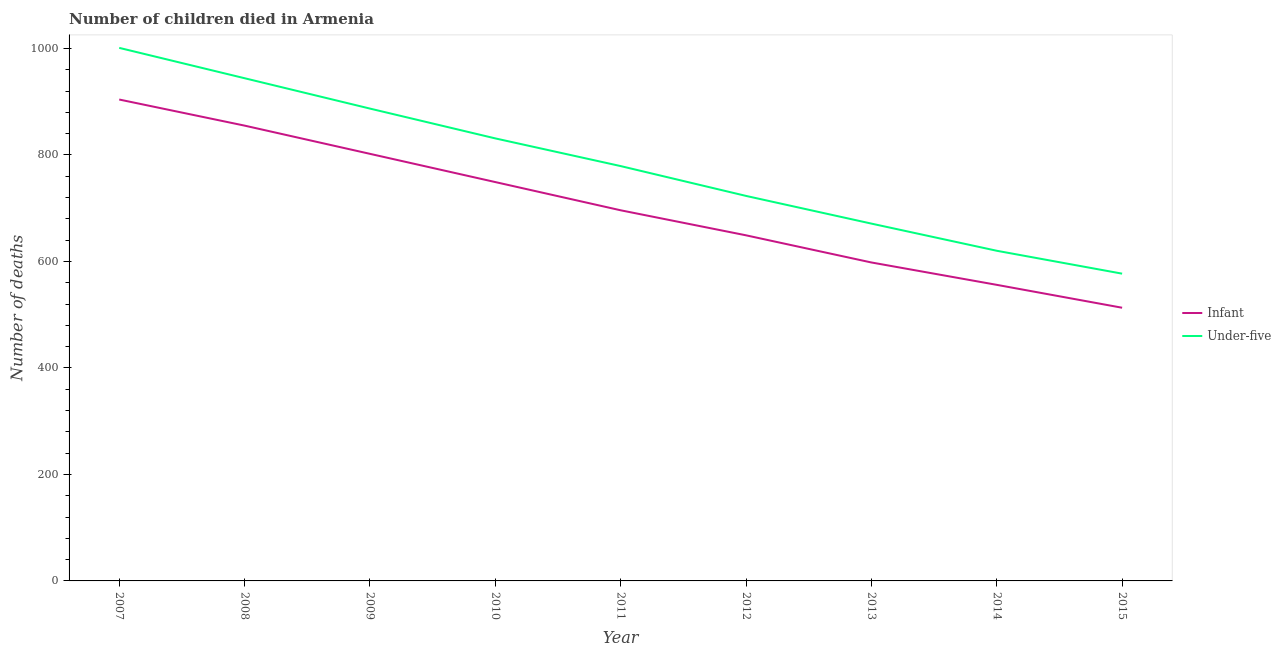How many different coloured lines are there?
Offer a very short reply. 2. Is the number of lines equal to the number of legend labels?
Offer a terse response. Yes. What is the number of infant deaths in 2015?
Make the answer very short. 513. Across all years, what is the maximum number of under-five deaths?
Provide a short and direct response. 1001. Across all years, what is the minimum number of infant deaths?
Keep it short and to the point. 513. In which year was the number of under-five deaths minimum?
Your response must be concise. 2015. What is the total number of under-five deaths in the graph?
Your answer should be compact. 7033. What is the difference between the number of under-five deaths in 2009 and that in 2013?
Keep it short and to the point. 216. What is the difference between the number of infant deaths in 2014 and the number of under-five deaths in 2009?
Provide a short and direct response. -331. What is the average number of under-five deaths per year?
Make the answer very short. 781.44. In the year 2009, what is the difference between the number of under-five deaths and number of infant deaths?
Provide a succinct answer. 85. What is the ratio of the number of infant deaths in 2011 to that in 2014?
Make the answer very short. 1.25. What is the difference between the highest and the lowest number of under-five deaths?
Make the answer very short. 424. Does the number of infant deaths monotonically increase over the years?
Offer a very short reply. No. Is the number of under-five deaths strictly less than the number of infant deaths over the years?
Your answer should be compact. No. How many lines are there?
Offer a terse response. 2. How many years are there in the graph?
Ensure brevity in your answer.  9. Are the values on the major ticks of Y-axis written in scientific E-notation?
Provide a short and direct response. No. Does the graph contain any zero values?
Ensure brevity in your answer.  No. Does the graph contain grids?
Provide a short and direct response. No. Where does the legend appear in the graph?
Provide a succinct answer. Center right. How many legend labels are there?
Ensure brevity in your answer.  2. How are the legend labels stacked?
Offer a very short reply. Vertical. What is the title of the graph?
Ensure brevity in your answer.  Number of children died in Armenia. What is the label or title of the Y-axis?
Ensure brevity in your answer.  Number of deaths. What is the Number of deaths in Infant in 2007?
Offer a terse response. 904. What is the Number of deaths in Under-five in 2007?
Give a very brief answer. 1001. What is the Number of deaths in Infant in 2008?
Provide a succinct answer. 855. What is the Number of deaths of Under-five in 2008?
Offer a very short reply. 944. What is the Number of deaths of Infant in 2009?
Offer a very short reply. 802. What is the Number of deaths in Under-five in 2009?
Your answer should be compact. 887. What is the Number of deaths in Infant in 2010?
Give a very brief answer. 749. What is the Number of deaths of Under-five in 2010?
Your answer should be compact. 831. What is the Number of deaths in Infant in 2011?
Your answer should be compact. 696. What is the Number of deaths in Under-five in 2011?
Provide a succinct answer. 779. What is the Number of deaths of Infant in 2012?
Offer a very short reply. 649. What is the Number of deaths in Under-five in 2012?
Ensure brevity in your answer.  723. What is the Number of deaths of Infant in 2013?
Keep it short and to the point. 598. What is the Number of deaths of Under-five in 2013?
Make the answer very short. 671. What is the Number of deaths of Infant in 2014?
Ensure brevity in your answer.  556. What is the Number of deaths of Under-five in 2014?
Ensure brevity in your answer.  620. What is the Number of deaths in Infant in 2015?
Give a very brief answer. 513. What is the Number of deaths in Under-five in 2015?
Provide a succinct answer. 577. Across all years, what is the maximum Number of deaths of Infant?
Your response must be concise. 904. Across all years, what is the maximum Number of deaths in Under-five?
Give a very brief answer. 1001. Across all years, what is the minimum Number of deaths in Infant?
Your answer should be very brief. 513. Across all years, what is the minimum Number of deaths in Under-five?
Offer a terse response. 577. What is the total Number of deaths of Infant in the graph?
Provide a succinct answer. 6322. What is the total Number of deaths of Under-five in the graph?
Your answer should be compact. 7033. What is the difference between the Number of deaths of Infant in 2007 and that in 2008?
Make the answer very short. 49. What is the difference between the Number of deaths in Infant in 2007 and that in 2009?
Your answer should be very brief. 102. What is the difference between the Number of deaths of Under-five in 2007 and that in 2009?
Ensure brevity in your answer.  114. What is the difference between the Number of deaths in Infant in 2007 and that in 2010?
Provide a short and direct response. 155. What is the difference between the Number of deaths in Under-five in 2007 and that in 2010?
Make the answer very short. 170. What is the difference between the Number of deaths of Infant in 2007 and that in 2011?
Provide a succinct answer. 208. What is the difference between the Number of deaths of Under-five in 2007 and that in 2011?
Provide a succinct answer. 222. What is the difference between the Number of deaths of Infant in 2007 and that in 2012?
Offer a very short reply. 255. What is the difference between the Number of deaths of Under-five in 2007 and that in 2012?
Offer a terse response. 278. What is the difference between the Number of deaths in Infant in 2007 and that in 2013?
Give a very brief answer. 306. What is the difference between the Number of deaths in Under-five in 2007 and that in 2013?
Provide a succinct answer. 330. What is the difference between the Number of deaths of Infant in 2007 and that in 2014?
Keep it short and to the point. 348. What is the difference between the Number of deaths in Under-five in 2007 and that in 2014?
Make the answer very short. 381. What is the difference between the Number of deaths in Infant in 2007 and that in 2015?
Provide a succinct answer. 391. What is the difference between the Number of deaths of Under-five in 2007 and that in 2015?
Offer a terse response. 424. What is the difference between the Number of deaths in Under-five in 2008 and that in 2009?
Offer a very short reply. 57. What is the difference between the Number of deaths of Infant in 2008 and that in 2010?
Your answer should be very brief. 106. What is the difference between the Number of deaths in Under-five in 2008 and that in 2010?
Offer a terse response. 113. What is the difference between the Number of deaths of Infant in 2008 and that in 2011?
Make the answer very short. 159. What is the difference between the Number of deaths of Under-five in 2008 and that in 2011?
Keep it short and to the point. 165. What is the difference between the Number of deaths of Infant in 2008 and that in 2012?
Offer a very short reply. 206. What is the difference between the Number of deaths in Under-five in 2008 and that in 2012?
Provide a short and direct response. 221. What is the difference between the Number of deaths in Infant in 2008 and that in 2013?
Your answer should be compact. 257. What is the difference between the Number of deaths in Under-five in 2008 and that in 2013?
Offer a very short reply. 273. What is the difference between the Number of deaths in Infant in 2008 and that in 2014?
Your answer should be very brief. 299. What is the difference between the Number of deaths of Under-five in 2008 and that in 2014?
Provide a short and direct response. 324. What is the difference between the Number of deaths in Infant in 2008 and that in 2015?
Offer a very short reply. 342. What is the difference between the Number of deaths in Under-five in 2008 and that in 2015?
Give a very brief answer. 367. What is the difference between the Number of deaths of Infant in 2009 and that in 2010?
Provide a succinct answer. 53. What is the difference between the Number of deaths of Under-five in 2009 and that in 2010?
Offer a terse response. 56. What is the difference between the Number of deaths in Infant in 2009 and that in 2011?
Provide a short and direct response. 106. What is the difference between the Number of deaths of Under-five in 2009 and that in 2011?
Offer a terse response. 108. What is the difference between the Number of deaths in Infant in 2009 and that in 2012?
Provide a succinct answer. 153. What is the difference between the Number of deaths of Under-five in 2009 and that in 2012?
Your response must be concise. 164. What is the difference between the Number of deaths of Infant in 2009 and that in 2013?
Your answer should be compact. 204. What is the difference between the Number of deaths of Under-five in 2009 and that in 2013?
Make the answer very short. 216. What is the difference between the Number of deaths in Infant in 2009 and that in 2014?
Your answer should be compact. 246. What is the difference between the Number of deaths in Under-five in 2009 and that in 2014?
Keep it short and to the point. 267. What is the difference between the Number of deaths of Infant in 2009 and that in 2015?
Ensure brevity in your answer.  289. What is the difference between the Number of deaths of Under-five in 2009 and that in 2015?
Your answer should be compact. 310. What is the difference between the Number of deaths of Infant in 2010 and that in 2011?
Your response must be concise. 53. What is the difference between the Number of deaths of Infant in 2010 and that in 2012?
Provide a short and direct response. 100. What is the difference between the Number of deaths of Under-five in 2010 and that in 2012?
Give a very brief answer. 108. What is the difference between the Number of deaths of Infant in 2010 and that in 2013?
Offer a very short reply. 151. What is the difference between the Number of deaths of Under-five in 2010 and that in 2013?
Provide a short and direct response. 160. What is the difference between the Number of deaths in Infant in 2010 and that in 2014?
Your response must be concise. 193. What is the difference between the Number of deaths in Under-five in 2010 and that in 2014?
Offer a terse response. 211. What is the difference between the Number of deaths in Infant in 2010 and that in 2015?
Provide a succinct answer. 236. What is the difference between the Number of deaths of Under-five in 2010 and that in 2015?
Your answer should be compact. 254. What is the difference between the Number of deaths in Under-five in 2011 and that in 2013?
Your answer should be very brief. 108. What is the difference between the Number of deaths of Infant in 2011 and that in 2014?
Offer a terse response. 140. What is the difference between the Number of deaths in Under-five in 2011 and that in 2014?
Offer a very short reply. 159. What is the difference between the Number of deaths in Infant in 2011 and that in 2015?
Make the answer very short. 183. What is the difference between the Number of deaths of Under-five in 2011 and that in 2015?
Ensure brevity in your answer.  202. What is the difference between the Number of deaths of Infant in 2012 and that in 2014?
Your response must be concise. 93. What is the difference between the Number of deaths of Under-five in 2012 and that in 2014?
Provide a succinct answer. 103. What is the difference between the Number of deaths of Infant in 2012 and that in 2015?
Keep it short and to the point. 136. What is the difference between the Number of deaths in Under-five in 2012 and that in 2015?
Keep it short and to the point. 146. What is the difference between the Number of deaths of Under-five in 2013 and that in 2014?
Your answer should be very brief. 51. What is the difference between the Number of deaths of Under-five in 2013 and that in 2015?
Your answer should be very brief. 94. What is the difference between the Number of deaths of Infant in 2014 and that in 2015?
Provide a short and direct response. 43. What is the difference between the Number of deaths of Infant in 2007 and the Number of deaths of Under-five in 2008?
Provide a short and direct response. -40. What is the difference between the Number of deaths of Infant in 2007 and the Number of deaths of Under-five in 2011?
Your answer should be compact. 125. What is the difference between the Number of deaths in Infant in 2007 and the Number of deaths in Under-five in 2012?
Provide a short and direct response. 181. What is the difference between the Number of deaths in Infant in 2007 and the Number of deaths in Under-five in 2013?
Your answer should be very brief. 233. What is the difference between the Number of deaths in Infant in 2007 and the Number of deaths in Under-five in 2014?
Your response must be concise. 284. What is the difference between the Number of deaths in Infant in 2007 and the Number of deaths in Under-five in 2015?
Give a very brief answer. 327. What is the difference between the Number of deaths of Infant in 2008 and the Number of deaths of Under-five in 2009?
Offer a very short reply. -32. What is the difference between the Number of deaths of Infant in 2008 and the Number of deaths of Under-five in 2011?
Offer a terse response. 76. What is the difference between the Number of deaths of Infant in 2008 and the Number of deaths of Under-five in 2012?
Make the answer very short. 132. What is the difference between the Number of deaths in Infant in 2008 and the Number of deaths in Under-five in 2013?
Your answer should be very brief. 184. What is the difference between the Number of deaths of Infant in 2008 and the Number of deaths of Under-five in 2014?
Offer a very short reply. 235. What is the difference between the Number of deaths of Infant in 2008 and the Number of deaths of Under-five in 2015?
Make the answer very short. 278. What is the difference between the Number of deaths in Infant in 2009 and the Number of deaths in Under-five in 2012?
Your response must be concise. 79. What is the difference between the Number of deaths of Infant in 2009 and the Number of deaths of Under-five in 2013?
Provide a succinct answer. 131. What is the difference between the Number of deaths of Infant in 2009 and the Number of deaths of Under-five in 2014?
Provide a succinct answer. 182. What is the difference between the Number of deaths in Infant in 2009 and the Number of deaths in Under-five in 2015?
Provide a short and direct response. 225. What is the difference between the Number of deaths in Infant in 2010 and the Number of deaths in Under-five in 2012?
Your response must be concise. 26. What is the difference between the Number of deaths of Infant in 2010 and the Number of deaths of Under-five in 2014?
Make the answer very short. 129. What is the difference between the Number of deaths of Infant in 2010 and the Number of deaths of Under-five in 2015?
Your response must be concise. 172. What is the difference between the Number of deaths of Infant in 2011 and the Number of deaths of Under-five in 2012?
Give a very brief answer. -27. What is the difference between the Number of deaths in Infant in 2011 and the Number of deaths in Under-five in 2015?
Offer a terse response. 119. What is the difference between the Number of deaths in Infant in 2012 and the Number of deaths in Under-five in 2013?
Provide a short and direct response. -22. What is the difference between the Number of deaths in Infant in 2013 and the Number of deaths in Under-five in 2015?
Ensure brevity in your answer.  21. What is the average Number of deaths of Infant per year?
Offer a terse response. 702.44. What is the average Number of deaths in Under-five per year?
Make the answer very short. 781.44. In the year 2007, what is the difference between the Number of deaths in Infant and Number of deaths in Under-five?
Your response must be concise. -97. In the year 2008, what is the difference between the Number of deaths of Infant and Number of deaths of Under-five?
Your response must be concise. -89. In the year 2009, what is the difference between the Number of deaths of Infant and Number of deaths of Under-five?
Offer a terse response. -85. In the year 2010, what is the difference between the Number of deaths of Infant and Number of deaths of Under-five?
Offer a terse response. -82. In the year 2011, what is the difference between the Number of deaths of Infant and Number of deaths of Under-five?
Offer a very short reply. -83. In the year 2012, what is the difference between the Number of deaths in Infant and Number of deaths in Under-five?
Give a very brief answer. -74. In the year 2013, what is the difference between the Number of deaths of Infant and Number of deaths of Under-five?
Give a very brief answer. -73. In the year 2014, what is the difference between the Number of deaths in Infant and Number of deaths in Under-five?
Give a very brief answer. -64. In the year 2015, what is the difference between the Number of deaths in Infant and Number of deaths in Under-five?
Offer a terse response. -64. What is the ratio of the Number of deaths in Infant in 2007 to that in 2008?
Your answer should be compact. 1.06. What is the ratio of the Number of deaths in Under-five in 2007 to that in 2008?
Your answer should be compact. 1.06. What is the ratio of the Number of deaths in Infant in 2007 to that in 2009?
Keep it short and to the point. 1.13. What is the ratio of the Number of deaths in Under-five in 2007 to that in 2009?
Provide a short and direct response. 1.13. What is the ratio of the Number of deaths of Infant in 2007 to that in 2010?
Your response must be concise. 1.21. What is the ratio of the Number of deaths in Under-five in 2007 to that in 2010?
Your answer should be compact. 1.2. What is the ratio of the Number of deaths in Infant in 2007 to that in 2011?
Ensure brevity in your answer.  1.3. What is the ratio of the Number of deaths in Under-five in 2007 to that in 2011?
Provide a short and direct response. 1.28. What is the ratio of the Number of deaths in Infant in 2007 to that in 2012?
Your answer should be compact. 1.39. What is the ratio of the Number of deaths of Under-five in 2007 to that in 2012?
Give a very brief answer. 1.38. What is the ratio of the Number of deaths in Infant in 2007 to that in 2013?
Ensure brevity in your answer.  1.51. What is the ratio of the Number of deaths of Under-five in 2007 to that in 2013?
Ensure brevity in your answer.  1.49. What is the ratio of the Number of deaths in Infant in 2007 to that in 2014?
Offer a very short reply. 1.63. What is the ratio of the Number of deaths in Under-five in 2007 to that in 2014?
Provide a short and direct response. 1.61. What is the ratio of the Number of deaths in Infant in 2007 to that in 2015?
Ensure brevity in your answer.  1.76. What is the ratio of the Number of deaths in Under-five in 2007 to that in 2015?
Your answer should be very brief. 1.73. What is the ratio of the Number of deaths of Infant in 2008 to that in 2009?
Keep it short and to the point. 1.07. What is the ratio of the Number of deaths in Under-five in 2008 to that in 2009?
Keep it short and to the point. 1.06. What is the ratio of the Number of deaths of Infant in 2008 to that in 2010?
Your answer should be compact. 1.14. What is the ratio of the Number of deaths in Under-five in 2008 to that in 2010?
Offer a very short reply. 1.14. What is the ratio of the Number of deaths in Infant in 2008 to that in 2011?
Provide a succinct answer. 1.23. What is the ratio of the Number of deaths in Under-five in 2008 to that in 2011?
Your answer should be very brief. 1.21. What is the ratio of the Number of deaths in Infant in 2008 to that in 2012?
Your answer should be compact. 1.32. What is the ratio of the Number of deaths in Under-five in 2008 to that in 2012?
Your answer should be very brief. 1.31. What is the ratio of the Number of deaths in Infant in 2008 to that in 2013?
Offer a very short reply. 1.43. What is the ratio of the Number of deaths of Under-five in 2008 to that in 2013?
Provide a short and direct response. 1.41. What is the ratio of the Number of deaths of Infant in 2008 to that in 2014?
Offer a very short reply. 1.54. What is the ratio of the Number of deaths of Under-five in 2008 to that in 2014?
Ensure brevity in your answer.  1.52. What is the ratio of the Number of deaths in Under-five in 2008 to that in 2015?
Give a very brief answer. 1.64. What is the ratio of the Number of deaths in Infant in 2009 to that in 2010?
Your response must be concise. 1.07. What is the ratio of the Number of deaths of Under-five in 2009 to that in 2010?
Keep it short and to the point. 1.07. What is the ratio of the Number of deaths in Infant in 2009 to that in 2011?
Offer a very short reply. 1.15. What is the ratio of the Number of deaths in Under-five in 2009 to that in 2011?
Provide a short and direct response. 1.14. What is the ratio of the Number of deaths of Infant in 2009 to that in 2012?
Keep it short and to the point. 1.24. What is the ratio of the Number of deaths of Under-five in 2009 to that in 2012?
Make the answer very short. 1.23. What is the ratio of the Number of deaths in Infant in 2009 to that in 2013?
Provide a short and direct response. 1.34. What is the ratio of the Number of deaths in Under-five in 2009 to that in 2013?
Offer a very short reply. 1.32. What is the ratio of the Number of deaths in Infant in 2009 to that in 2014?
Provide a short and direct response. 1.44. What is the ratio of the Number of deaths of Under-five in 2009 to that in 2014?
Provide a succinct answer. 1.43. What is the ratio of the Number of deaths of Infant in 2009 to that in 2015?
Give a very brief answer. 1.56. What is the ratio of the Number of deaths of Under-five in 2009 to that in 2015?
Give a very brief answer. 1.54. What is the ratio of the Number of deaths of Infant in 2010 to that in 2011?
Offer a very short reply. 1.08. What is the ratio of the Number of deaths in Under-five in 2010 to that in 2011?
Offer a terse response. 1.07. What is the ratio of the Number of deaths of Infant in 2010 to that in 2012?
Keep it short and to the point. 1.15. What is the ratio of the Number of deaths of Under-five in 2010 to that in 2012?
Provide a short and direct response. 1.15. What is the ratio of the Number of deaths of Infant in 2010 to that in 2013?
Your answer should be very brief. 1.25. What is the ratio of the Number of deaths in Under-five in 2010 to that in 2013?
Your response must be concise. 1.24. What is the ratio of the Number of deaths of Infant in 2010 to that in 2014?
Ensure brevity in your answer.  1.35. What is the ratio of the Number of deaths in Under-five in 2010 to that in 2014?
Your answer should be compact. 1.34. What is the ratio of the Number of deaths of Infant in 2010 to that in 2015?
Ensure brevity in your answer.  1.46. What is the ratio of the Number of deaths in Under-five in 2010 to that in 2015?
Ensure brevity in your answer.  1.44. What is the ratio of the Number of deaths in Infant in 2011 to that in 2012?
Keep it short and to the point. 1.07. What is the ratio of the Number of deaths in Under-five in 2011 to that in 2012?
Provide a short and direct response. 1.08. What is the ratio of the Number of deaths in Infant in 2011 to that in 2013?
Provide a succinct answer. 1.16. What is the ratio of the Number of deaths of Under-five in 2011 to that in 2013?
Keep it short and to the point. 1.16. What is the ratio of the Number of deaths of Infant in 2011 to that in 2014?
Your answer should be very brief. 1.25. What is the ratio of the Number of deaths of Under-five in 2011 to that in 2014?
Provide a short and direct response. 1.26. What is the ratio of the Number of deaths of Infant in 2011 to that in 2015?
Offer a terse response. 1.36. What is the ratio of the Number of deaths of Under-five in 2011 to that in 2015?
Your response must be concise. 1.35. What is the ratio of the Number of deaths in Infant in 2012 to that in 2013?
Keep it short and to the point. 1.09. What is the ratio of the Number of deaths of Under-five in 2012 to that in 2013?
Provide a short and direct response. 1.08. What is the ratio of the Number of deaths of Infant in 2012 to that in 2014?
Keep it short and to the point. 1.17. What is the ratio of the Number of deaths in Under-five in 2012 to that in 2014?
Offer a very short reply. 1.17. What is the ratio of the Number of deaths of Infant in 2012 to that in 2015?
Your response must be concise. 1.27. What is the ratio of the Number of deaths in Under-five in 2012 to that in 2015?
Provide a succinct answer. 1.25. What is the ratio of the Number of deaths of Infant in 2013 to that in 2014?
Keep it short and to the point. 1.08. What is the ratio of the Number of deaths of Under-five in 2013 to that in 2014?
Provide a short and direct response. 1.08. What is the ratio of the Number of deaths of Infant in 2013 to that in 2015?
Keep it short and to the point. 1.17. What is the ratio of the Number of deaths in Under-five in 2013 to that in 2015?
Give a very brief answer. 1.16. What is the ratio of the Number of deaths in Infant in 2014 to that in 2015?
Keep it short and to the point. 1.08. What is the ratio of the Number of deaths of Under-five in 2014 to that in 2015?
Ensure brevity in your answer.  1.07. What is the difference between the highest and the second highest Number of deaths in Under-five?
Provide a short and direct response. 57. What is the difference between the highest and the lowest Number of deaths of Infant?
Give a very brief answer. 391. What is the difference between the highest and the lowest Number of deaths of Under-five?
Give a very brief answer. 424. 